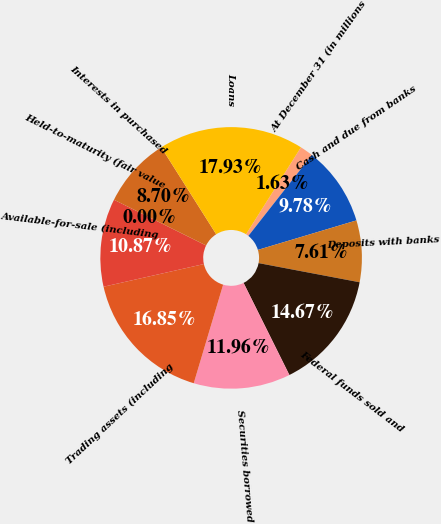Convert chart to OTSL. <chart><loc_0><loc_0><loc_500><loc_500><pie_chart><fcel>At December 31 (in millions<fcel>Cash and due from banks<fcel>Deposits with banks<fcel>Federal funds sold and<fcel>Securities borrowed<fcel>Trading assets (including<fcel>Available-for-sale (including<fcel>Held-to-maturity (fair value<fcel>Interests in purchased<fcel>Loans<nl><fcel>1.63%<fcel>9.78%<fcel>7.61%<fcel>14.67%<fcel>11.96%<fcel>16.85%<fcel>10.87%<fcel>0.0%<fcel>8.7%<fcel>17.93%<nl></chart> 